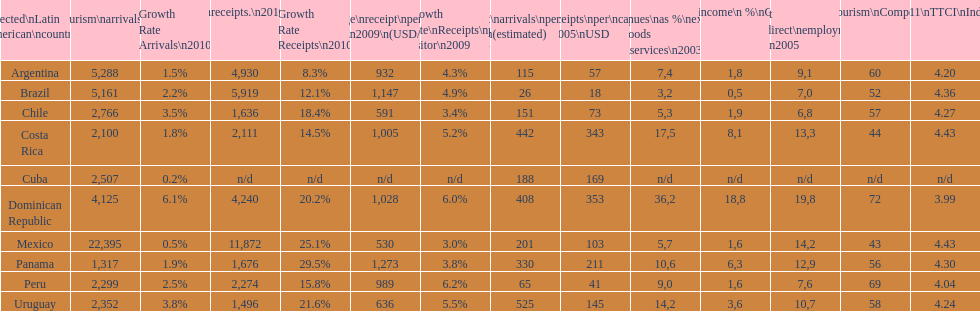What is the last country listed on this chart? Uruguay. 